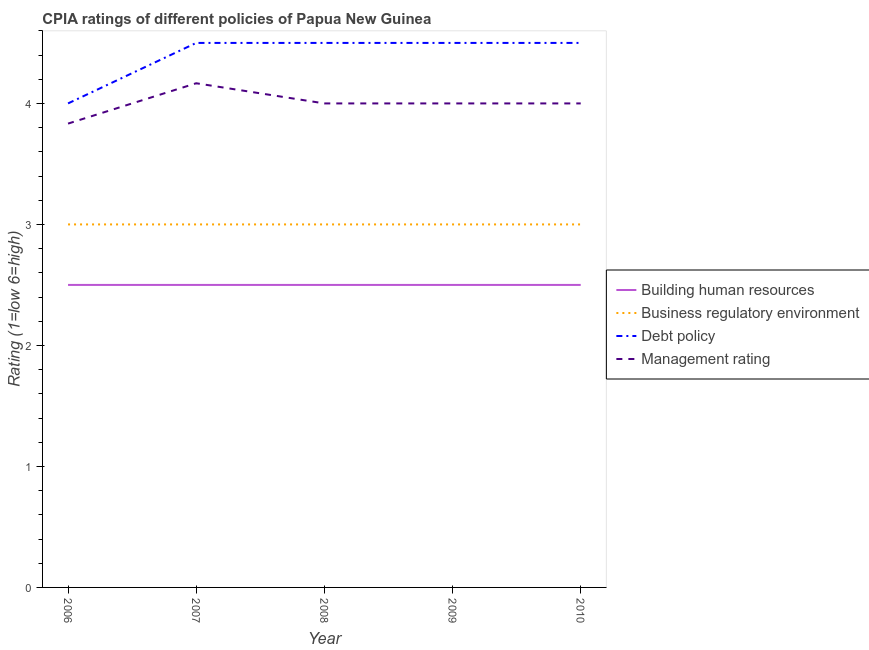How many different coloured lines are there?
Provide a short and direct response. 4. Is the number of lines equal to the number of legend labels?
Your answer should be very brief. Yes. Across all years, what is the maximum cpia rating of building human resources?
Ensure brevity in your answer.  2.5. Across all years, what is the minimum cpia rating of business regulatory environment?
Your answer should be very brief. 3. In which year was the cpia rating of debt policy minimum?
Provide a short and direct response. 2006. What is the difference between the cpia rating of debt policy in 2007 and that in 2008?
Offer a very short reply. 0. In the year 2006, what is the difference between the cpia rating of business regulatory environment and cpia rating of management?
Offer a terse response. -0.83. In how many years, is the cpia rating of debt policy greater than 4.4?
Your answer should be very brief. 4. Is the difference between the cpia rating of business regulatory environment in 2006 and 2009 greater than the difference between the cpia rating of management in 2006 and 2009?
Provide a short and direct response. Yes. What is the difference between the highest and the lowest cpia rating of management?
Give a very brief answer. 0.33. In how many years, is the cpia rating of debt policy greater than the average cpia rating of debt policy taken over all years?
Your response must be concise. 4. Is the sum of the cpia rating of debt policy in 2007 and 2009 greater than the maximum cpia rating of business regulatory environment across all years?
Ensure brevity in your answer.  Yes. Does the cpia rating of management monotonically increase over the years?
Your response must be concise. No. Is the cpia rating of building human resources strictly greater than the cpia rating of debt policy over the years?
Your response must be concise. No. Does the graph contain grids?
Keep it short and to the point. No. How many legend labels are there?
Provide a short and direct response. 4. What is the title of the graph?
Provide a succinct answer. CPIA ratings of different policies of Papua New Guinea. What is the label or title of the X-axis?
Ensure brevity in your answer.  Year. What is the Rating (1=low 6=high) of Building human resources in 2006?
Provide a short and direct response. 2.5. What is the Rating (1=low 6=high) in Debt policy in 2006?
Your response must be concise. 4. What is the Rating (1=low 6=high) of Management rating in 2006?
Your answer should be very brief. 3.83. What is the Rating (1=low 6=high) of Business regulatory environment in 2007?
Your answer should be compact. 3. What is the Rating (1=low 6=high) in Management rating in 2007?
Your answer should be compact. 4.17. What is the Rating (1=low 6=high) of Debt policy in 2008?
Offer a very short reply. 4.5. What is the Rating (1=low 6=high) of Building human resources in 2009?
Keep it short and to the point. 2.5. What is the Rating (1=low 6=high) in Business regulatory environment in 2009?
Offer a terse response. 3. What is the Rating (1=low 6=high) in Management rating in 2009?
Give a very brief answer. 4. What is the Rating (1=low 6=high) of Building human resources in 2010?
Provide a succinct answer. 2.5. What is the Rating (1=low 6=high) of Business regulatory environment in 2010?
Make the answer very short. 3. Across all years, what is the maximum Rating (1=low 6=high) in Business regulatory environment?
Your answer should be very brief. 3. Across all years, what is the maximum Rating (1=low 6=high) in Debt policy?
Your response must be concise. 4.5. Across all years, what is the maximum Rating (1=low 6=high) in Management rating?
Your answer should be compact. 4.17. Across all years, what is the minimum Rating (1=low 6=high) in Building human resources?
Offer a terse response. 2.5. Across all years, what is the minimum Rating (1=low 6=high) in Debt policy?
Offer a terse response. 4. Across all years, what is the minimum Rating (1=low 6=high) of Management rating?
Keep it short and to the point. 3.83. What is the total Rating (1=low 6=high) in Business regulatory environment in the graph?
Your answer should be compact. 15. What is the difference between the Rating (1=low 6=high) in Building human resources in 2006 and that in 2008?
Your answer should be compact. 0. What is the difference between the Rating (1=low 6=high) of Debt policy in 2006 and that in 2009?
Provide a short and direct response. -0.5. What is the difference between the Rating (1=low 6=high) of Management rating in 2006 and that in 2009?
Ensure brevity in your answer.  -0.17. What is the difference between the Rating (1=low 6=high) of Building human resources in 2006 and that in 2010?
Your answer should be compact. 0. What is the difference between the Rating (1=low 6=high) of Building human resources in 2007 and that in 2008?
Ensure brevity in your answer.  0. What is the difference between the Rating (1=low 6=high) of Business regulatory environment in 2007 and that in 2008?
Make the answer very short. 0. What is the difference between the Rating (1=low 6=high) of Building human resources in 2007 and that in 2009?
Your answer should be very brief. 0. What is the difference between the Rating (1=low 6=high) of Building human resources in 2007 and that in 2010?
Provide a short and direct response. 0. What is the difference between the Rating (1=low 6=high) of Business regulatory environment in 2007 and that in 2010?
Make the answer very short. 0. What is the difference between the Rating (1=low 6=high) of Debt policy in 2007 and that in 2010?
Your response must be concise. 0. What is the difference between the Rating (1=low 6=high) of Debt policy in 2008 and that in 2009?
Your answer should be very brief. 0. What is the difference between the Rating (1=low 6=high) in Management rating in 2008 and that in 2009?
Keep it short and to the point. 0. What is the difference between the Rating (1=low 6=high) of Business regulatory environment in 2008 and that in 2010?
Make the answer very short. 0. What is the difference between the Rating (1=low 6=high) of Debt policy in 2008 and that in 2010?
Your answer should be compact. 0. What is the difference between the Rating (1=low 6=high) of Debt policy in 2009 and that in 2010?
Your response must be concise. 0. What is the difference between the Rating (1=low 6=high) of Building human resources in 2006 and the Rating (1=low 6=high) of Debt policy in 2007?
Offer a very short reply. -2. What is the difference between the Rating (1=low 6=high) of Building human resources in 2006 and the Rating (1=low 6=high) of Management rating in 2007?
Your response must be concise. -1.67. What is the difference between the Rating (1=low 6=high) of Business regulatory environment in 2006 and the Rating (1=low 6=high) of Management rating in 2007?
Provide a succinct answer. -1.17. What is the difference between the Rating (1=low 6=high) of Building human resources in 2006 and the Rating (1=low 6=high) of Business regulatory environment in 2008?
Offer a very short reply. -0.5. What is the difference between the Rating (1=low 6=high) of Building human resources in 2006 and the Rating (1=low 6=high) of Debt policy in 2008?
Offer a very short reply. -2. What is the difference between the Rating (1=low 6=high) of Debt policy in 2006 and the Rating (1=low 6=high) of Management rating in 2008?
Ensure brevity in your answer.  0. What is the difference between the Rating (1=low 6=high) in Building human resources in 2006 and the Rating (1=low 6=high) in Debt policy in 2009?
Offer a very short reply. -2. What is the difference between the Rating (1=low 6=high) of Building human resources in 2006 and the Rating (1=low 6=high) of Business regulatory environment in 2010?
Provide a short and direct response. -0.5. What is the difference between the Rating (1=low 6=high) in Business regulatory environment in 2006 and the Rating (1=low 6=high) in Debt policy in 2010?
Give a very brief answer. -1.5. What is the difference between the Rating (1=low 6=high) of Debt policy in 2006 and the Rating (1=low 6=high) of Management rating in 2010?
Provide a short and direct response. 0. What is the difference between the Rating (1=low 6=high) in Building human resources in 2007 and the Rating (1=low 6=high) in Debt policy in 2008?
Ensure brevity in your answer.  -2. What is the difference between the Rating (1=low 6=high) of Building human resources in 2007 and the Rating (1=low 6=high) of Management rating in 2008?
Provide a succinct answer. -1.5. What is the difference between the Rating (1=low 6=high) in Business regulatory environment in 2007 and the Rating (1=low 6=high) in Management rating in 2008?
Your answer should be very brief. -1. What is the difference between the Rating (1=low 6=high) of Debt policy in 2007 and the Rating (1=low 6=high) of Management rating in 2008?
Offer a terse response. 0.5. What is the difference between the Rating (1=low 6=high) of Building human resources in 2007 and the Rating (1=low 6=high) of Debt policy in 2009?
Your response must be concise. -2. What is the difference between the Rating (1=low 6=high) of Debt policy in 2007 and the Rating (1=low 6=high) of Management rating in 2009?
Ensure brevity in your answer.  0.5. What is the difference between the Rating (1=low 6=high) of Building human resources in 2007 and the Rating (1=low 6=high) of Business regulatory environment in 2010?
Your answer should be very brief. -0.5. What is the difference between the Rating (1=low 6=high) of Building human resources in 2007 and the Rating (1=low 6=high) of Debt policy in 2010?
Give a very brief answer. -2. What is the difference between the Rating (1=low 6=high) of Business regulatory environment in 2007 and the Rating (1=low 6=high) of Management rating in 2010?
Offer a terse response. -1. What is the difference between the Rating (1=low 6=high) in Building human resources in 2008 and the Rating (1=low 6=high) in Business regulatory environment in 2009?
Offer a terse response. -0.5. What is the difference between the Rating (1=low 6=high) in Building human resources in 2008 and the Rating (1=low 6=high) in Debt policy in 2009?
Provide a short and direct response. -2. What is the difference between the Rating (1=low 6=high) of Business regulatory environment in 2008 and the Rating (1=low 6=high) of Debt policy in 2009?
Keep it short and to the point. -1.5. What is the difference between the Rating (1=low 6=high) of Building human resources in 2008 and the Rating (1=low 6=high) of Business regulatory environment in 2010?
Give a very brief answer. -0.5. What is the difference between the Rating (1=low 6=high) of Building human resources in 2008 and the Rating (1=low 6=high) of Debt policy in 2010?
Your response must be concise. -2. What is the difference between the Rating (1=low 6=high) of Building human resources in 2009 and the Rating (1=low 6=high) of Management rating in 2010?
Keep it short and to the point. -1.5. What is the difference between the Rating (1=low 6=high) of Business regulatory environment in 2009 and the Rating (1=low 6=high) of Management rating in 2010?
Make the answer very short. -1. What is the difference between the Rating (1=low 6=high) of Debt policy in 2009 and the Rating (1=low 6=high) of Management rating in 2010?
Offer a very short reply. 0.5. What is the average Rating (1=low 6=high) in Business regulatory environment per year?
Your answer should be compact. 3. What is the average Rating (1=low 6=high) of Debt policy per year?
Make the answer very short. 4.4. What is the average Rating (1=low 6=high) of Management rating per year?
Ensure brevity in your answer.  4. In the year 2006, what is the difference between the Rating (1=low 6=high) of Building human resources and Rating (1=low 6=high) of Debt policy?
Provide a succinct answer. -1.5. In the year 2006, what is the difference between the Rating (1=low 6=high) of Building human resources and Rating (1=low 6=high) of Management rating?
Give a very brief answer. -1.33. In the year 2006, what is the difference between the Rating (1=low 6=high) in Business regulatory environment and Rating (1=low 6=high) in Debt policy?
Give a very brief answer. -1. In the year 2006, what is the difference between the Rating (1=low 6=high) in Business regulatory environment and Rating (1=low 6=high) in Management rating?
Keep it short and to the point. -0.83. In the year 2006, what is the difference between the Rating (1=low 6=high) of Debt policy and Rating (1=low 6=high) of Management rating?
Your answer should be compact. 0.17. In the year 2007, what is the difference between the Rating (1=low 6=high) of Building human resources and Rating (1=low 6=high) of Debt policy?
Ensure brevity in your answer.  -2. In the year 2007, what is the difference between the Rating (1=low 6=high) of Building human resources and Rating (1=low 6=high) of Management rating?
Provide a short and direct response. -1.67. In the year 2007, what is the difference between the Rating (1=low 6=high) of Business regulatory environment and Rating (1=low 6=high) of Debt policy?
Ensure brevity in your answer.  -1.5. In the year 2007, what is the difference between the Rating (1=low 6=high) of Business regulatory environment and Rating (1=low 6=high) of Management rating?
Provide a short and direct response. -1.17. In the year 2008, what is the difference between the Rating (1=low 6=high) of Building human resources and Rating (1=low 6=high) of Debt policy?
Your response must be concise. -2. In the year 2008, what is the difference between the Rating (1=low 6=high) in Debt policy and Rating (1=low 6=high) in Management rating?
Keep it short and to the point. 0.5. In the year 2009, what is the difference between the Rating (1=low 6=high) of Building human resources and Rating (1=low 6=high) of Business regulatory environment?
Your answer should be compact. -0.5. In the year 2009, what is the difference between the Rating (1=low 6=high) of Business regulatory environment and Rating (1=low 6=high) of Debt policy?
Your answer should be very brief. -1.5. In the year 2010, what is the difference between the Rating (1=low 6=high) in Building human resources and Rating (1=low 6=high) in Management rating?
Make the answer very short. -1.5. In the year 2010, what is the difference between the Rating (1=low 6=high) of Business regulatory environment and Rating (1=low 6=high) of Management rating?
Give a very brief answer. -1. What is the ratio of the Rating (1=low 6=high) in Building human resources in 2006 to that in 2007?
Keep it short and to the point. 1. What is the ratio of the Rating (1=low 6=high) of Debt policy in 2006 to that in 2007?
Provide a succinct answer. 0.89. What is the ratio of the Rating (1=low 6=high) of Business regulatory environment in 2006 to that in 2008?
Provide a short and direct response. 1. What is the ratio of the Rating (1=low 6=high) of Debt policy in 2006 to that in 2008?
Ensure brevity in your answer.  0.89. What is the ratio of the Rating (1=low 6=high) of Building human resources in 2006 to that in 2009?
Give a very brief answer. 1. What is the ratio of the Rating (1=low 6=high) of Business regulatory environment in 2006 to that in 2009?
Give a very brief answer. 1. What is the ratio of the Rating (1=low 6=high) in Management rating in 2006 to that in 2009?
Give a very brief answer. 0.96. What is the ratio of the Rating (1=low 6=high) in Management rating in 2006 to that in 2010?
Offer a very short reply. 0.96. What is the ratio of the Rating (1=low 6=high) in Building human resources in 2007 to that in 2008?
Give a very brief answer. 1. What is the ratio of the Rating (1=low 6=high) in Management rating in 2007 to that in 2008?
Ensure brevity in your answer.  1.04. What is the ratio of the Rating (1=low 6=high) in Business regulatory environment in 2007 to that in 2009?
Your answer should be compact. 1. What is the ratio of the Rating (1=low 6=high) in Management rating in 2007 to that in 2009?
Provide a succinct answer. 1.04. What is the ratio of the Rating (1=low 6=high) of Building human resources in 2007 to that in 2010?
Your response must be concise. 1. What is the ratio of the Rating (1=low 6=high) of Business regulatory environment in 2007 to that in 2010?
Offer a very short reply. 1. What is the ratio of the Rating (1=low 6=high) in Management rating in 2007 to that in 2010?
Your answer should be very brief. 1.04. What is the ratio of the Rating (1=low 6=high) of Business regulatory environment in 2008 to that in 2009?
Provide a succinct answer. 1. What is the ratio of the Rating (1=low 6=high) in Debt policy in 2008 to that in 2009?
Provide a short and direct response. 1. What is the ratio of the Rating (1=low 6=high) of Business regulatory environment in 2008 to that in 2010?
Offer a very short reply. 1. What is the ratio of the Rating (1=low 6=high) in Building human resources in 2009 to that in 2010?
Make the answer very short. 1. What is the ratio of the Rating (1=low 6=high) in Debt policy in 2009 to that in 2010?
Offer a very short reply. 1. What is the ratio of the Rating (1=low 6=high) of Management rating in 2009 to that in 2010?
Your response must be concise. 1. What is the difference between the highest and the second highest Rating (1=low 6=high) of Building human resources?
Provide a short and direct response. 0. What is the difference between the highest and the second highest Rating (1=low 6=high) of Business regulatory environment?
Provide a short and direct response. 0. What is the difference between the highest and the lowest Rating (1=low 6=high) of Management rating?
Give a very brief answer. 0.33. 